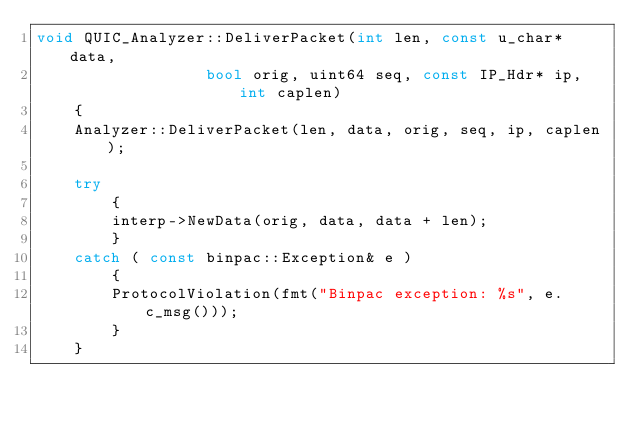<code> <loc_0><loc_0><loc_500><loc_500><_C++_>void QUIC_Analyzer::DeliverPacket(int len, const u_char* data,
	 			  bool orig, uint64 seq, const IP_Hdr* ip, int caplen)
	{
	Analyzer::DeliverPacket(len, data, orig, seq, ip, caplen);

	try
		{
		interp->NewData(orig, data, data + len);
		}
	catch ( const binpac::Exception& e )
		{
		ProtocolViolation(fmt("Binpac exception: %s", e.c_msg()));
		}
	}
</code> 